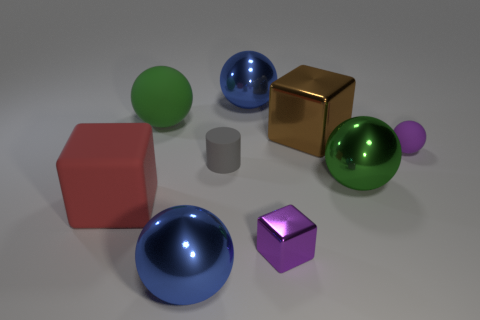Imagine these objects are part of a set. What sort of theme do you think they convey together? Envisioning them as a set, these objects might suggest a theme of diversity in unity; a collection where each item is a variant of basic geometric shapes, categorized by properties such as color, material, and size. This ensemble could symbolize the concept that individual uniqueness contributes to a larger harmonious whole. 